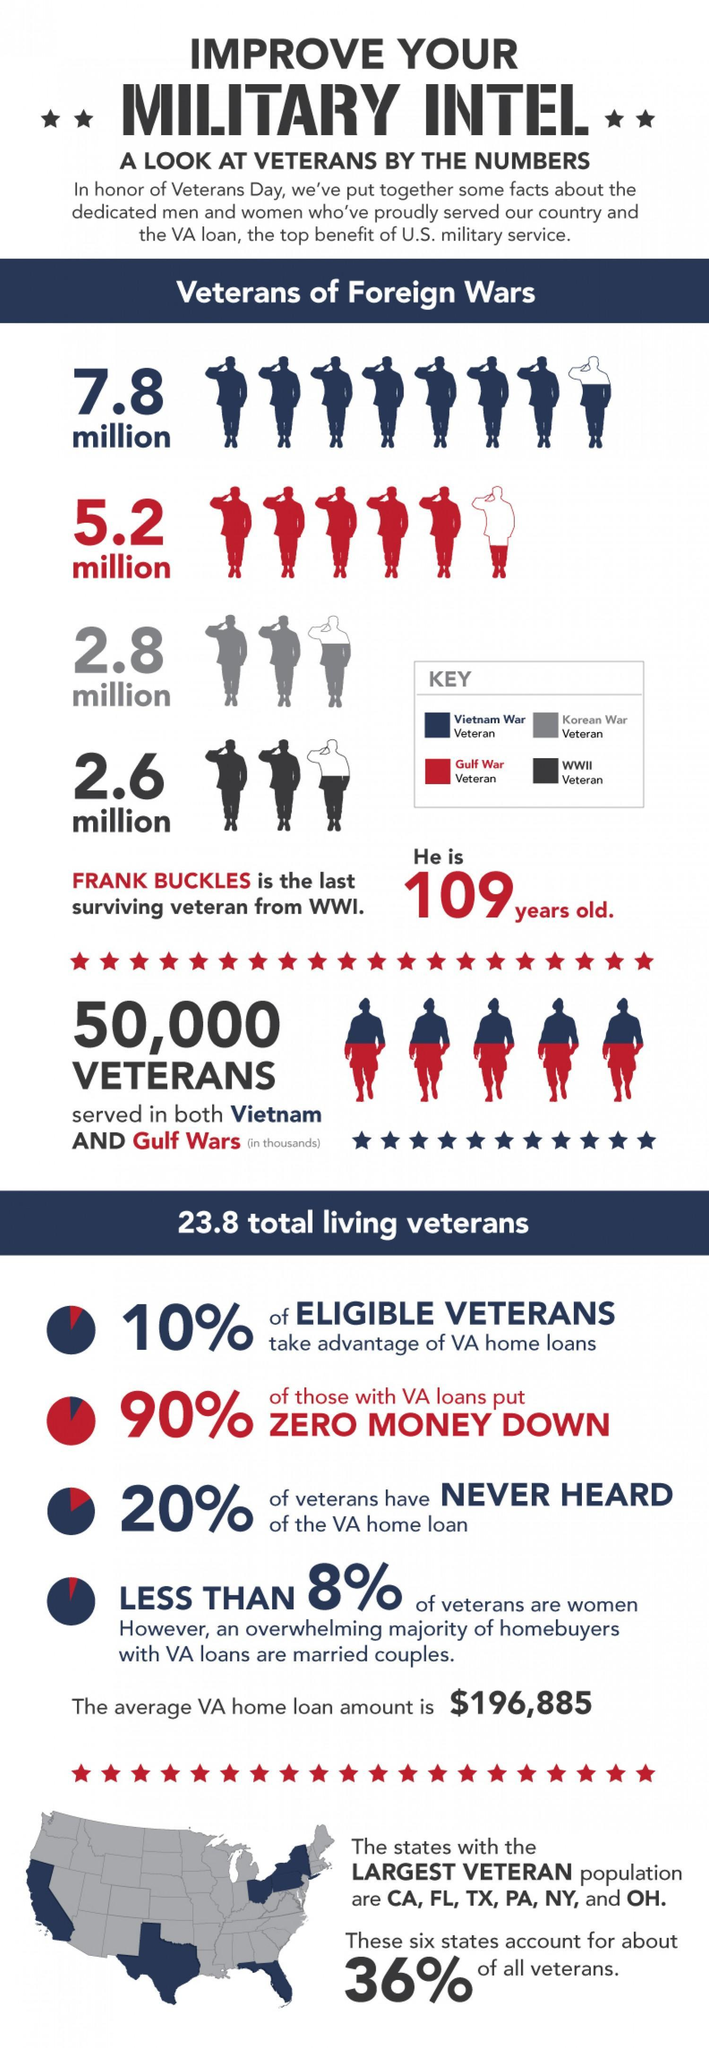How many American veterans served in the Second World War?
Answer the question with a short phrase. 2.6 million What is the age of the last living veteran of the First World War? 109 years old. How many American veterans served in the Gulf War? 5.2 million What is the number of American veterans  who served in the Vietnam war? 7.8 million 